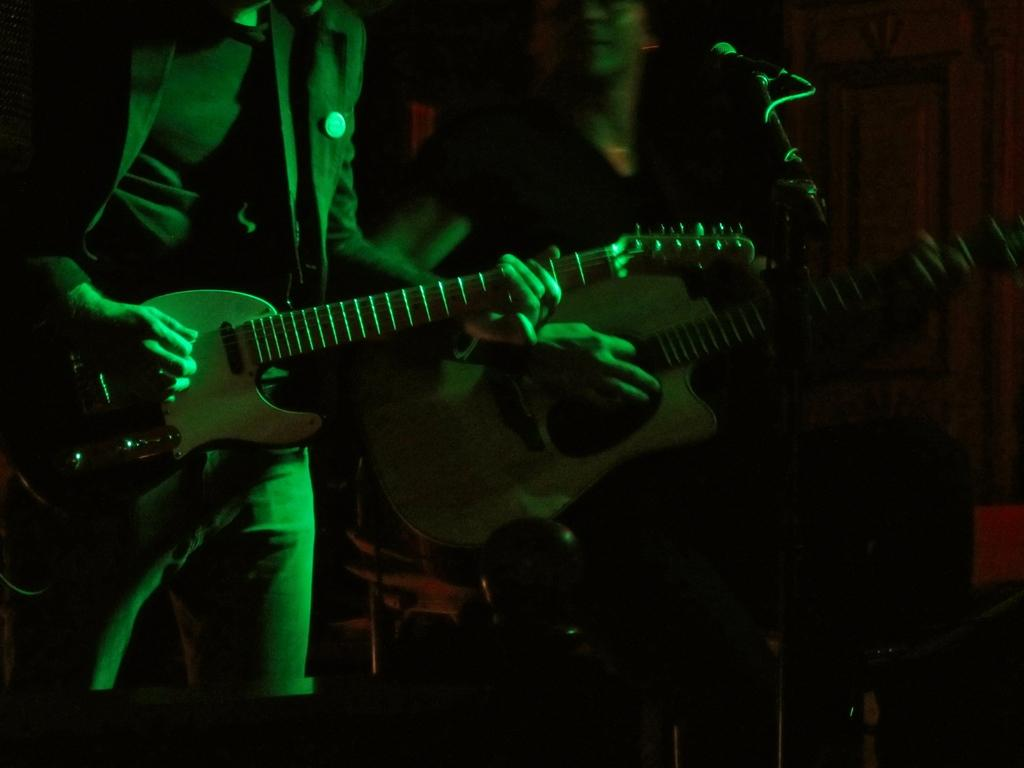How many people are in the image? There are two people in the image. What are the two people holding? The two people are holding guitars. What are the two people doing with the guitars? The two people are playing the guitars. What is in front of the two people? There is a microphone in front of the two people. How would you describe the lighting in the image? The image is taken in a dark setting. What type of board can be seen in the image? There is no board present in the image. What advice is the person on the left giving to the person on the right? There is no conversation or advice-giving depicted in the image; the two people are playing guitars. 